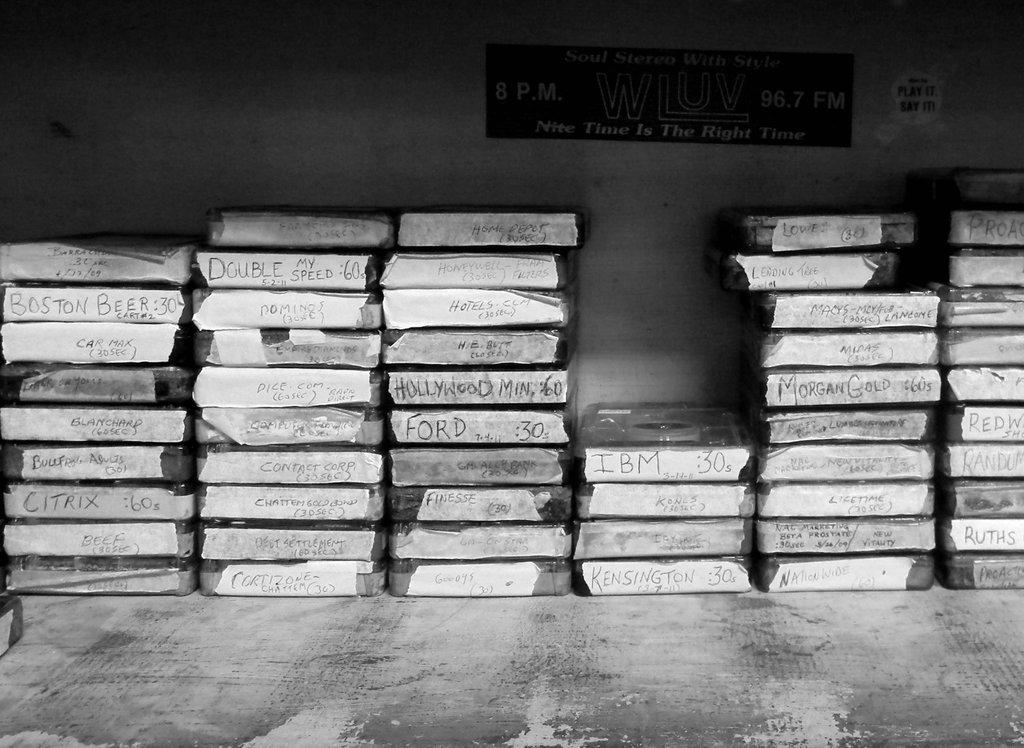<image>
Relay a brief, clear account of the picture shown. Stacks of cassette cases with hand written titles on the edges stacked on a gray table by a wall 